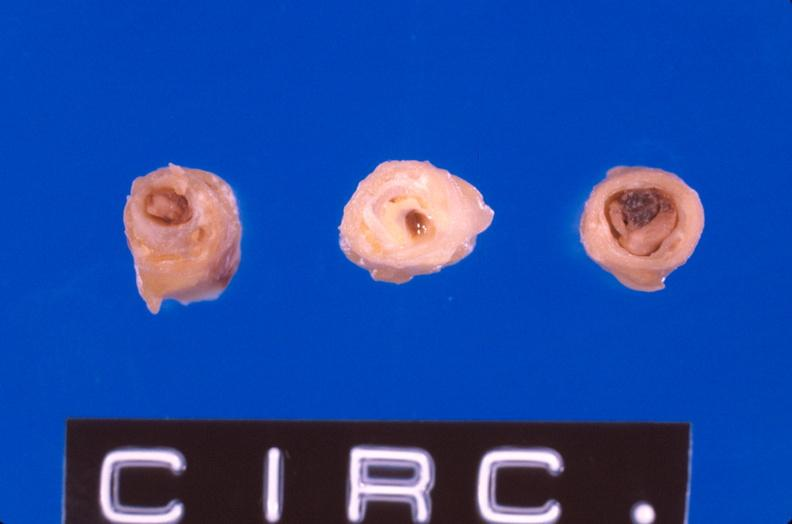where is this?
Answer the question using a single word or phrase. Vasculature 